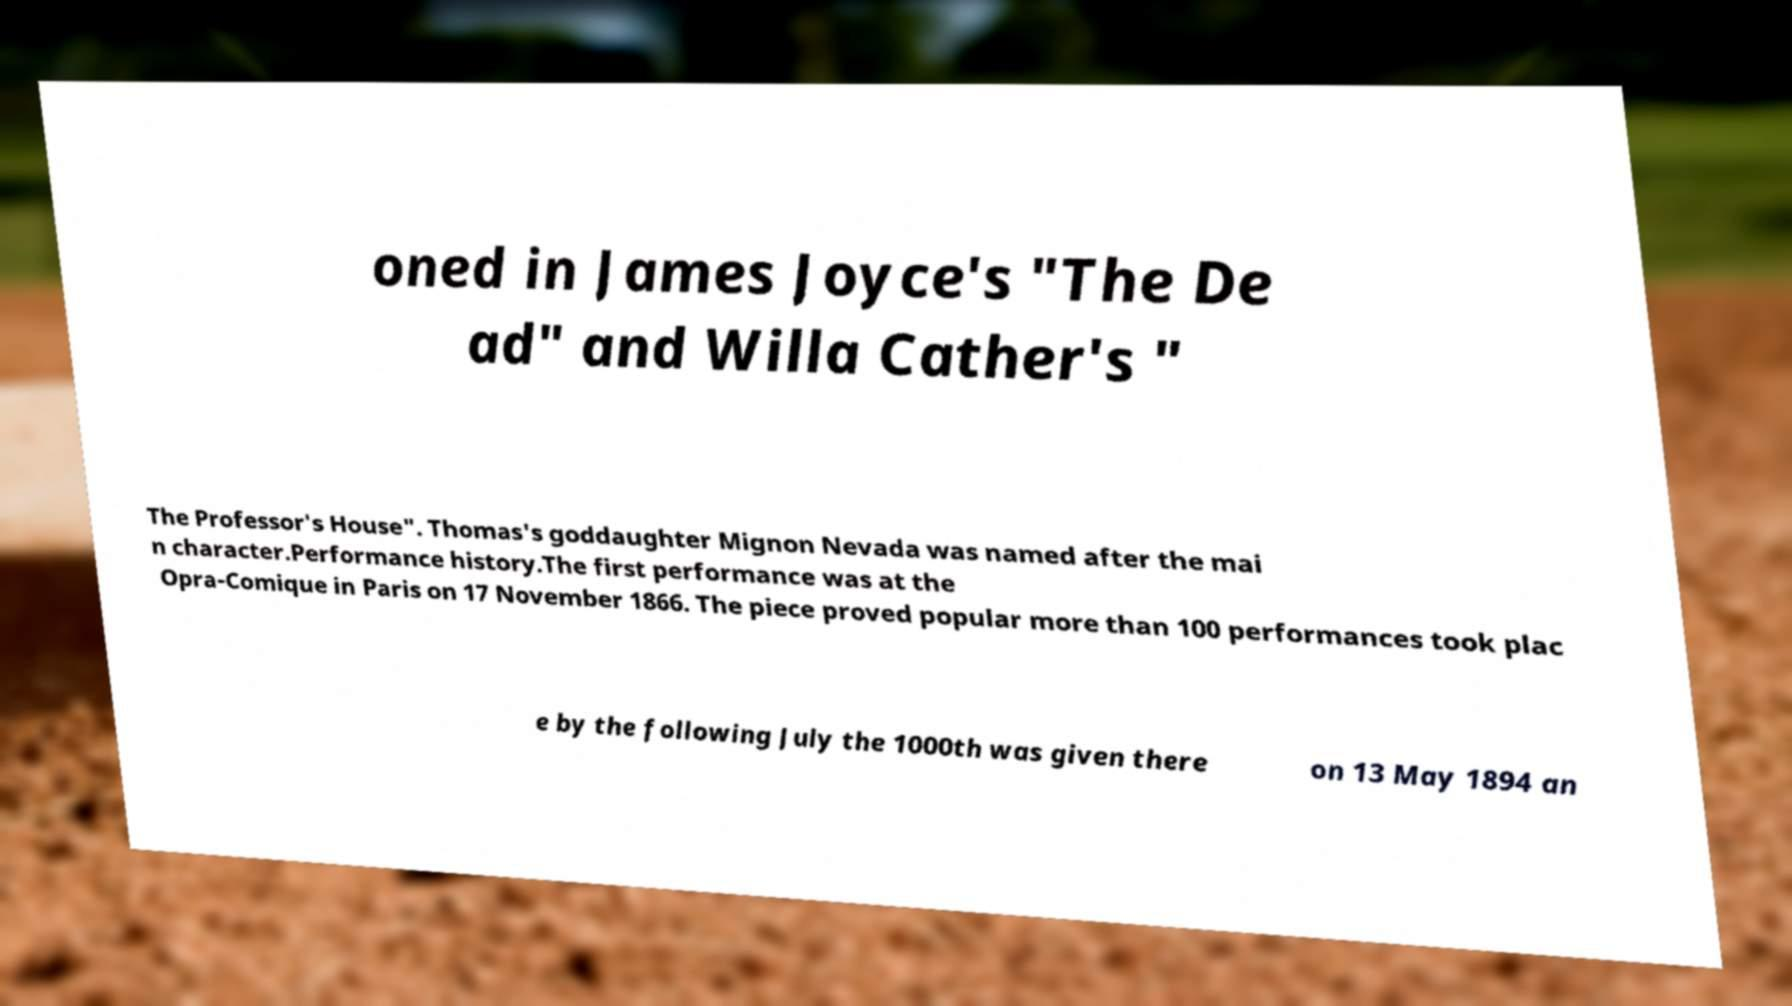Could you assist in decoding the text presented in this image and type it out clearly? oned in James Joyce's "The De ad" and Willa Cather's " The Professor's House". Thomas's goddaughter Mignon Nevada was named after the mai n character.Performance history.The first performance was at the Opra-Comique in Paris on 17 November 1866. The piece proved popular more than 100 performances took plac e by the following July the 1000th was given there on 13 May 1894 an 